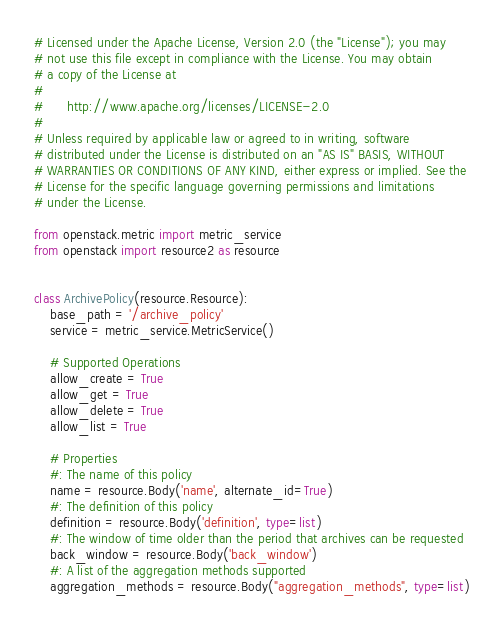<code> <loc_0><loc_0><loc_500><loc_500><_Python_># Licensed under the Apache License, Version 2.0 (the "License"); you may
# not use this file except in compliance with the License. You may obtain
# a copy of the License at
#
#      http://www.apache.org/licenses/LICENSE-2.0
#
# Unless required by applicable law or agreed to in writing, software
# distributed under the License is distributed on an "AS IS" BASIS, WITHOUT
# WARRANTIES OR CONDITIONS OF ANY KIND, either express or implied. See the
# License for the specific language governing permissions and limitations
# under the License.

from openstack.metric import metric_service
from openstack import resource2 as resource


class ArchivePolicy(resource.Resource):
    base_path = '/archive_policy'
    service = metric_service.MetricService()

    # Supported Operations
    allow_create = True
    allow_get = True
    allow_delete = True
    allow_list = True

    # Properties
    #: The name of this policy
    name = resource.Body('name', alternate_id=True)
    #: The definition of this policy
    definition = resource.Body('definition', type=list)
    #: The window of time older than the period that archives can be requested
    back_window = resource.Body('back_window')
    #: A list of the aggregation methods supported
    aggregation_methods = resource.Body("aggregation_methods", type=list)
</code> 